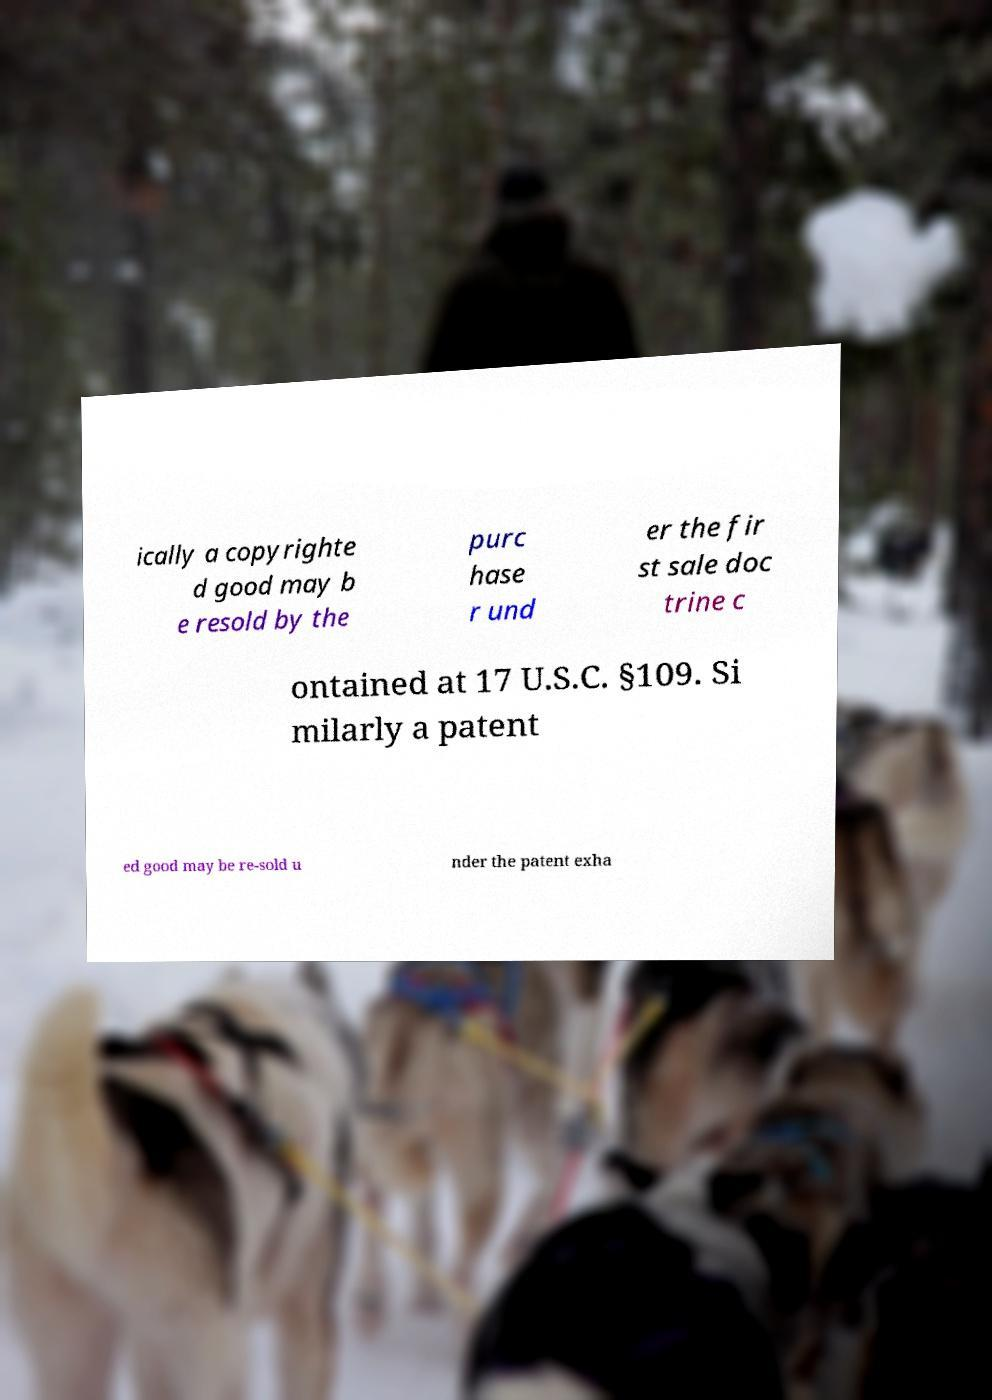Can you read and provide the text displayed in the image?This photo seems to have some interesting text. Can you extract and type it out for me? ically a copyrighte d good may b e resold by the purc hase r und er the fir st sale doc trine c ontained at 17 U.S.C. §109. Si milarly a patent ed good may be re-sold u nder the patent exha 